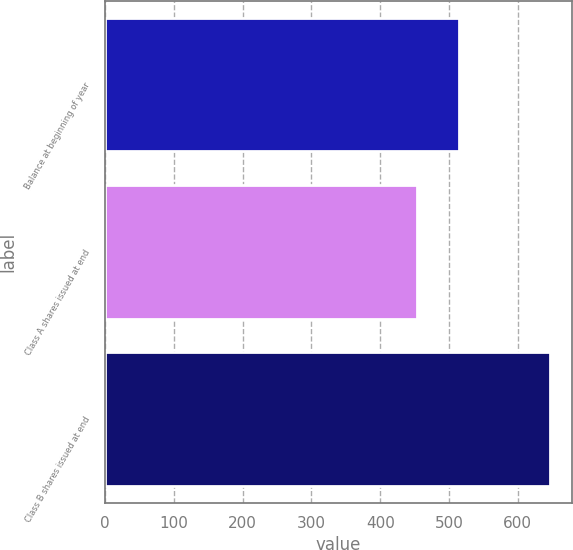<chart> <loc_0><loc_0><loc_500><loc_500><bar_chart><fcel>Balance at beginning of year<fcel>Class A shares issued at end<fcel>Class B shares issued at end<nl><fcel>515<fcel>454<fcel>646<nl></chart> 